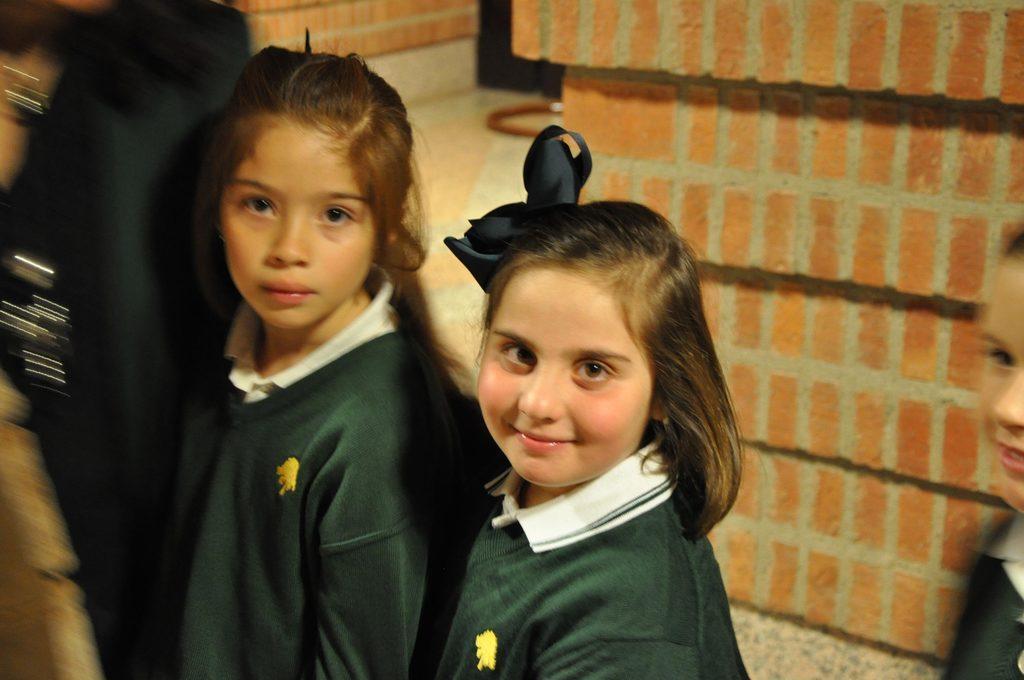Please provide a concise description of this image. In this image we can see girls standing. In the background there is a brick wall. 